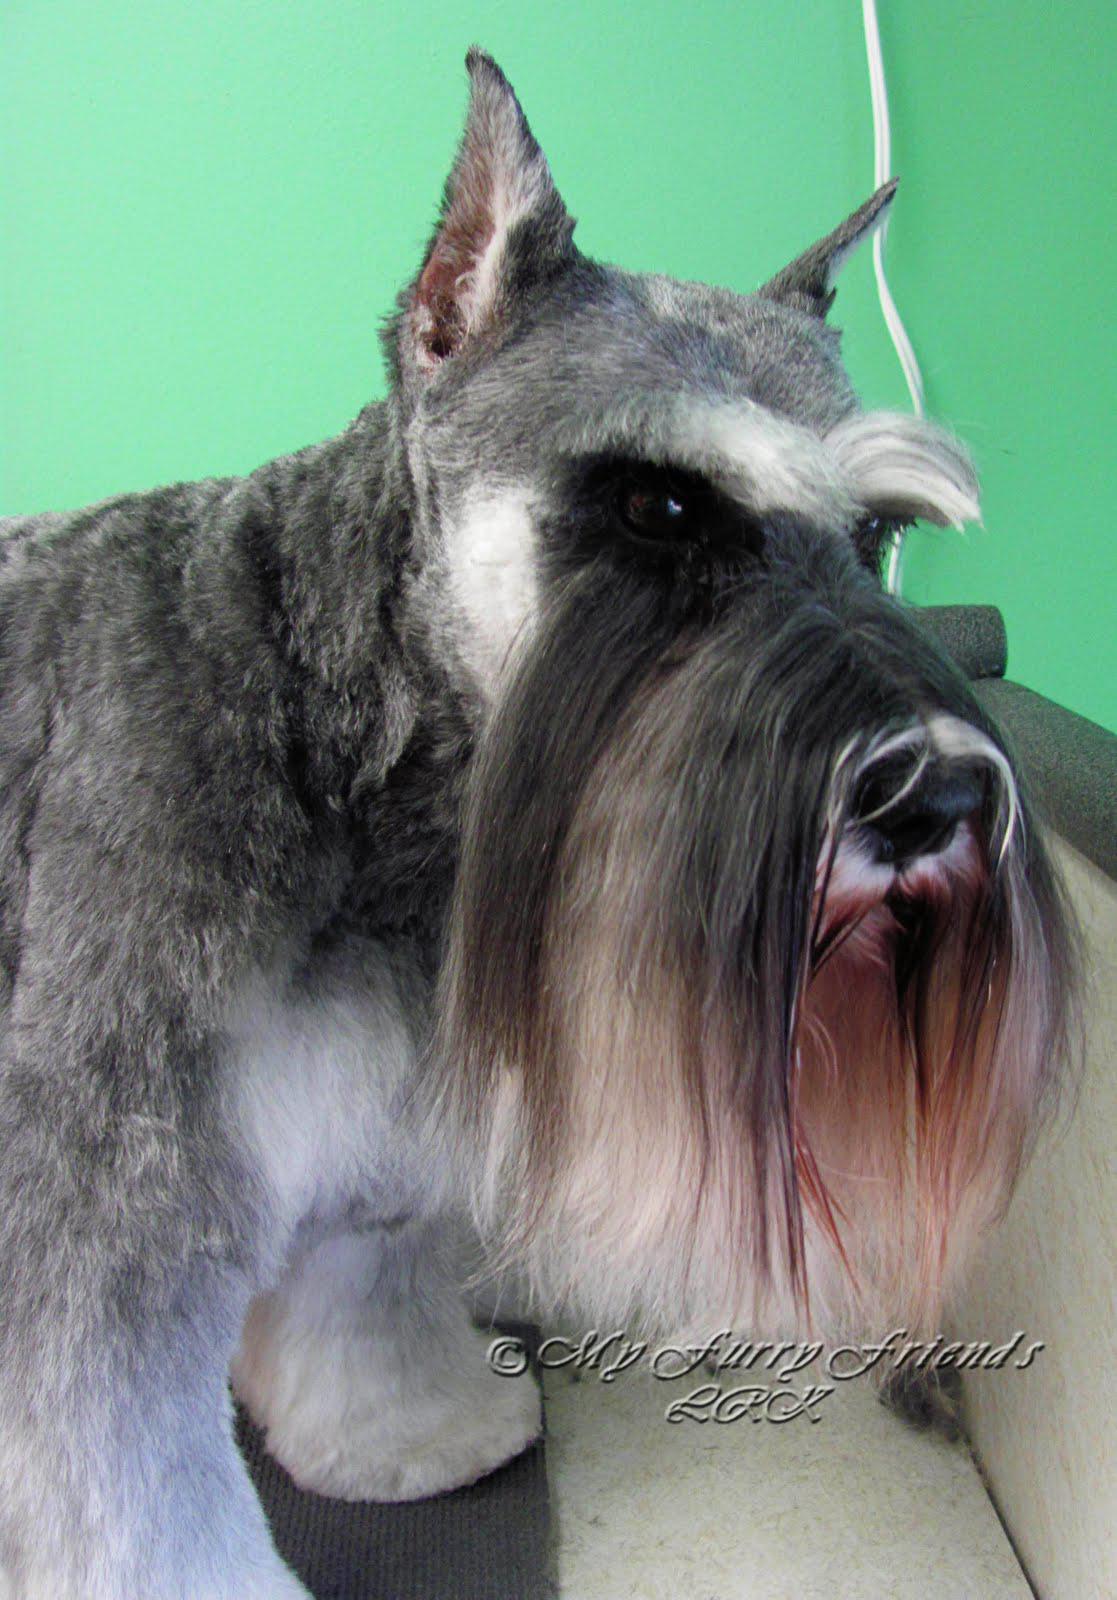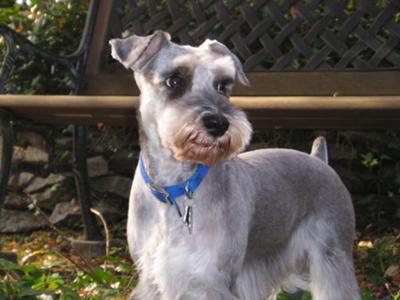The first image is the image on the left, the second image is the image on the right. Examine the images to the left and right. Is the description "Schnauzer in the left image is wearing a kind of bandana around its neck." accurate? Answer yes or no. No. The first image is the image on the left, the second image is the image on the right. Examine the images to the left and right. Is the description "the dog in the image on the right is wearing a collar" accurate? Answer yes or no. Yes. 